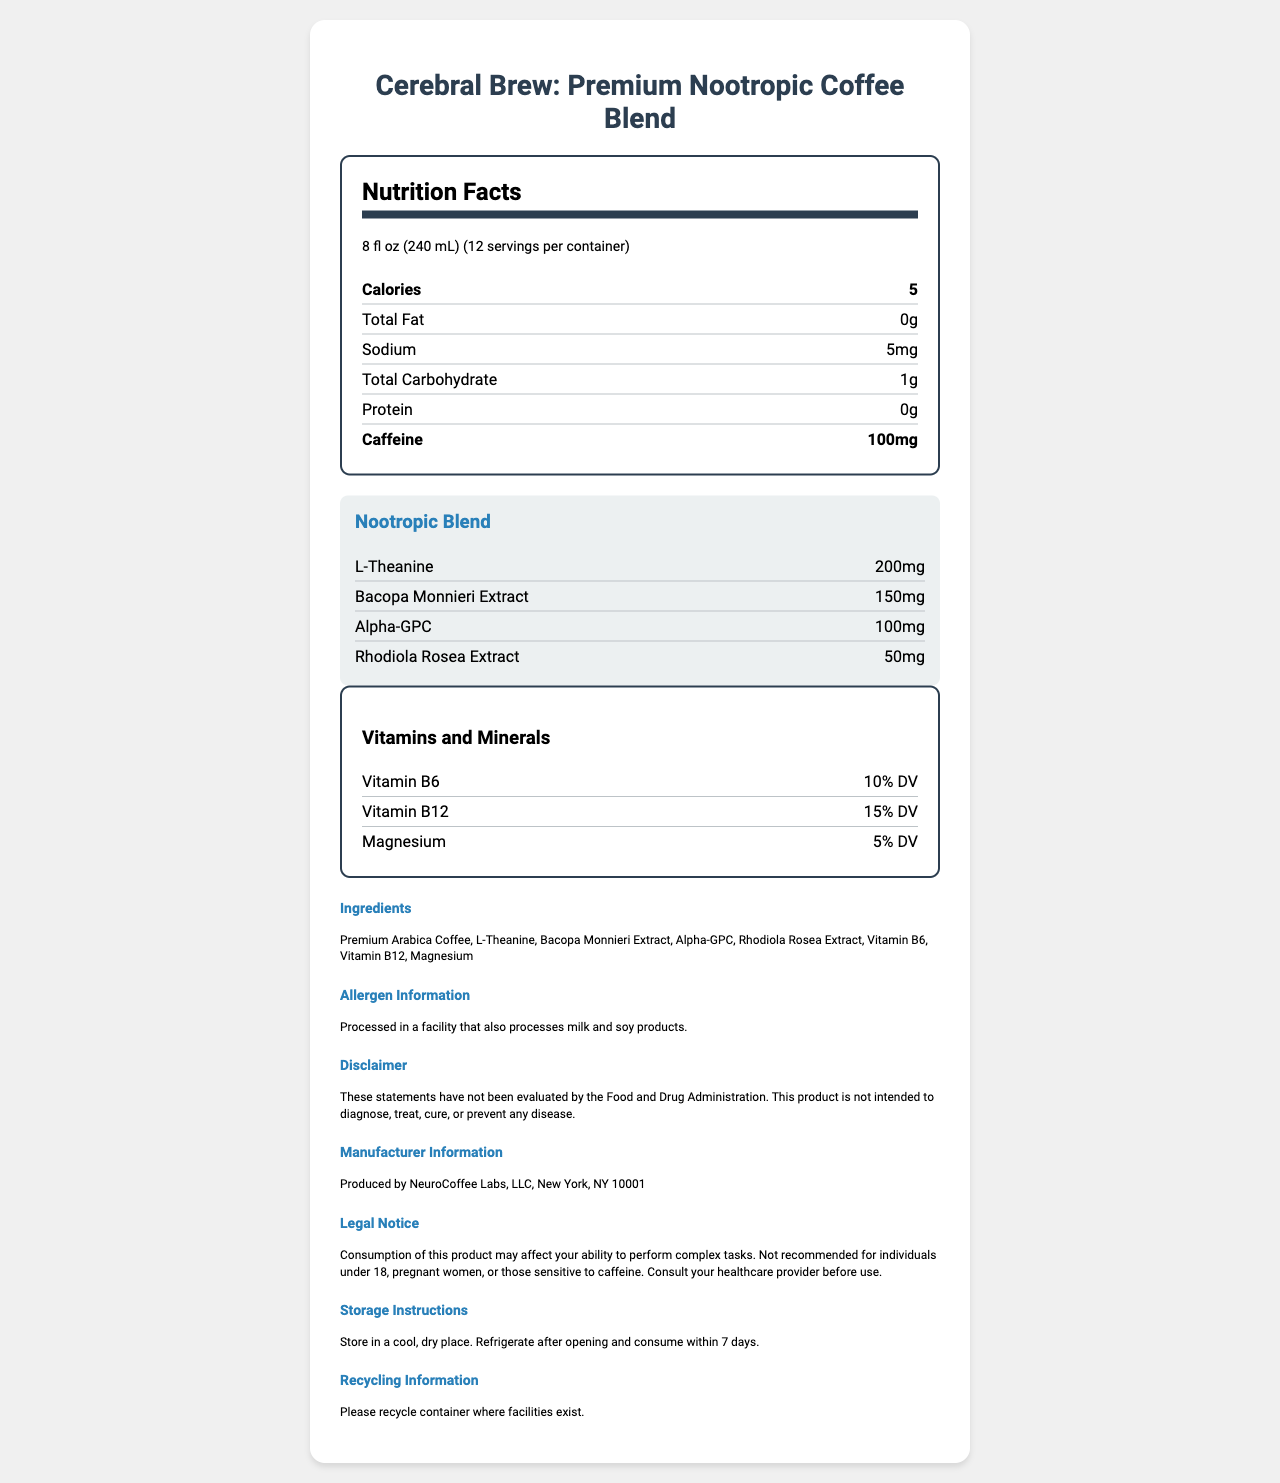what is the serving size? The serving size is mentioned in the "serving info" section of the nutrition facts.
Answer: 8 fl oz (240 mL) how many calories are in one serving? The number of calories per serving is listed in the first bold nutrient row under the nutrition facts.
Answer: 5 what is the total carbohydrate content per serving? The total carbohydrate content per serving is shown under the nutrient row labeled "Total Carbohydrate".
Answer: 1g how much caffeine does each serving contain? The caffeine content per serving is listed in the second bold nutrient row under the nutrition facts.
Answer: 100mg what nootropic blend components are included in this coffee? The nootropic blend components are listed in a special section labeled "Nootropic Blend".
Answer: L-Theanine, Bacopa Monnieri Extract, Alpha-GPC, Rhodiola Rosea Extract what percentage of daily value (DV) for Vitamin B12 is contained in each serving? The percentage of daily value for Vitamin B12 is listed in the "Vitamins and Minerals" section.
Answer: 15% DV what type of coffee is used in this product? A. Robusta B. Arabica C. Espresso D. Instant The ingredients list states "Premium Arabica Coffee".
Answer: B which of the following is NOT an ingredient in "Cerebral Brew: Premium Nootropic Coffee Blend"? I. L-Theanine II. Vitamin C III. Magnesium Vitamin C is not listed among the ingredients; the others are.
Answer: II is this coffee product processed in a facility that processes milk and soy products? The allergen information section clearly states that it is processed in a facility that also processes milk and soy products.
Answer: Yes does the document mention if this product is suitable for individuals under 18? The legal notice states "Not recommended for individuals under 18".
Answer: No what is the primary function hinted at by the product name and description? The product name "Cerebral Brew: Premium Nootropic Coffee Blend" and the inclusion of nootropic ingredients suggest it is intended for cognitive enhancement.
Answer: Cognitive enhancement describe the entire document. The document provides comprehensive nutritional and product details for "Cerebral Brew", highlighting its nootropic ingredients for cognitive benefits.
Answer: The document is a nutrition facts label for "Cerebral Brew: Premium Nootropic Coffee Blend". It includes serving size, nutritional information (calories, fats, sodium, carbohydrates, protein, and caffeine), and details about the nootropic blend (L-Theanine, Bacopa Monnieri Extract, Alpha-GPC, Rhodiola Rosea Extract). It lists vitamins and minerals, ingredients, allergen information, disclaimers, manufacturer information, legal notices, storage instructions, and recycling information. what is the exact location of the manufacturing facility? The manufacturer info section provides the location as "Produced by NeuroCoffee Labs, LLC, New York, NY 10001".
Answer: NeuroCoffee Labs, LLC, New York, NY 10001 what is the recommended storage condition for this coffee after opening? The storage instructions state to refrigerate the product after opening and consume it within 7 days.
Answer: Refrigerate after opening and consume within 7 days what is the percentage of magnesium in this product? According to the "Vitamins and Minerals" section, each serving contains 5% of the daily value for magnesium.
Answer: 5% DV how many servings are in one container? The "serving info" section states that there are 12 servings per container.
Answer: 12 can we determine if this product is gluten-free from the document? The document does not provide any information regarding whether the product is gluten-free.
Answer: Cannot be determined 